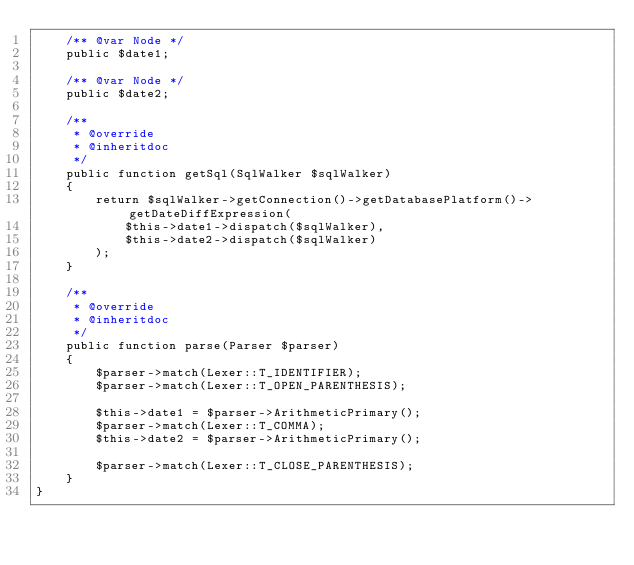Convert code to text. <code><loc_0><loc_0><loc_500><loc_500><_PHP_>    /** @var Node */
    public $date1;

    /** @var Node */
    public $date2;

    /**
     * @override
     * @inheritdoc
     */
    public function getSql(SqlWalker $sqlWalker)
    {
        return $sqlWalker->getConnection()->getDatabasePlatform()->getDateDiffExpression(
            $this->date1->dispatch($sqlWalker),
            $this->date2->dispatch($sqlWalker)
        );
    }

    /**
     * @override
     * @inheritdoc
     */
    public function parse(Parser $parser)
    {
        $parser->match(Lexer::T_IDENTIFIER);
        $parser->match(Lexer::T_OPEN_PARENTHESIS);

        $this->date1 = $parser->ArithmeticPrimary();
        $parser->match(Lexer::T_COMMA);
        $this->date2 = $parser->ArithmeticPrimary();

        $parser->match(Lexer::T_CLOSE_PARENTHESIS);
    }
}
</code> 